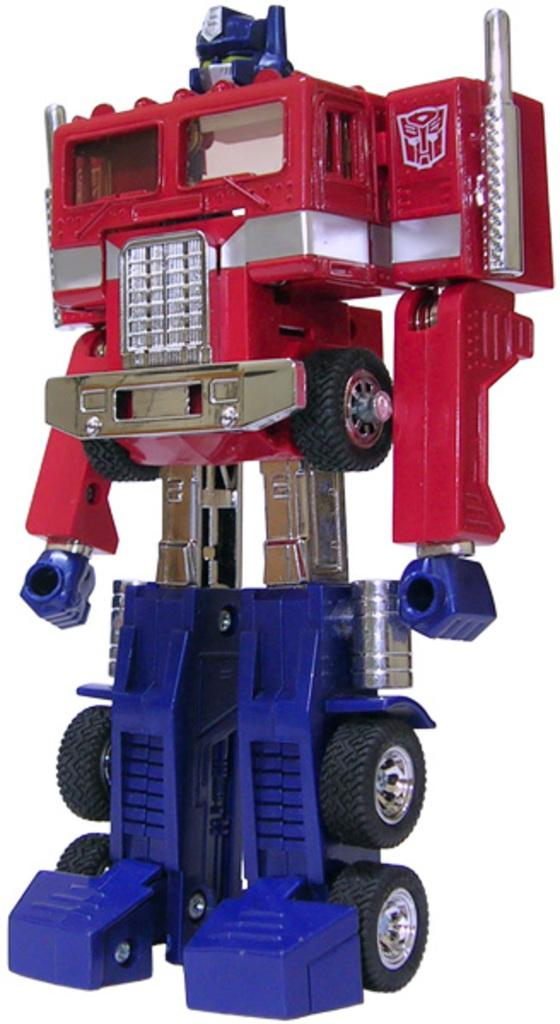What type of object is depicted in the image? The object is a toy. Can you describe any specific features of the toy? The toy has tires. How many visitors can be seen interacting with the toy on the slope in the image? There is no slope or visitors present in the image; it only features a toy with tires. What type of ring is visible on the toy in the image? There is no ring present on the toy in the image; it only has tires. 